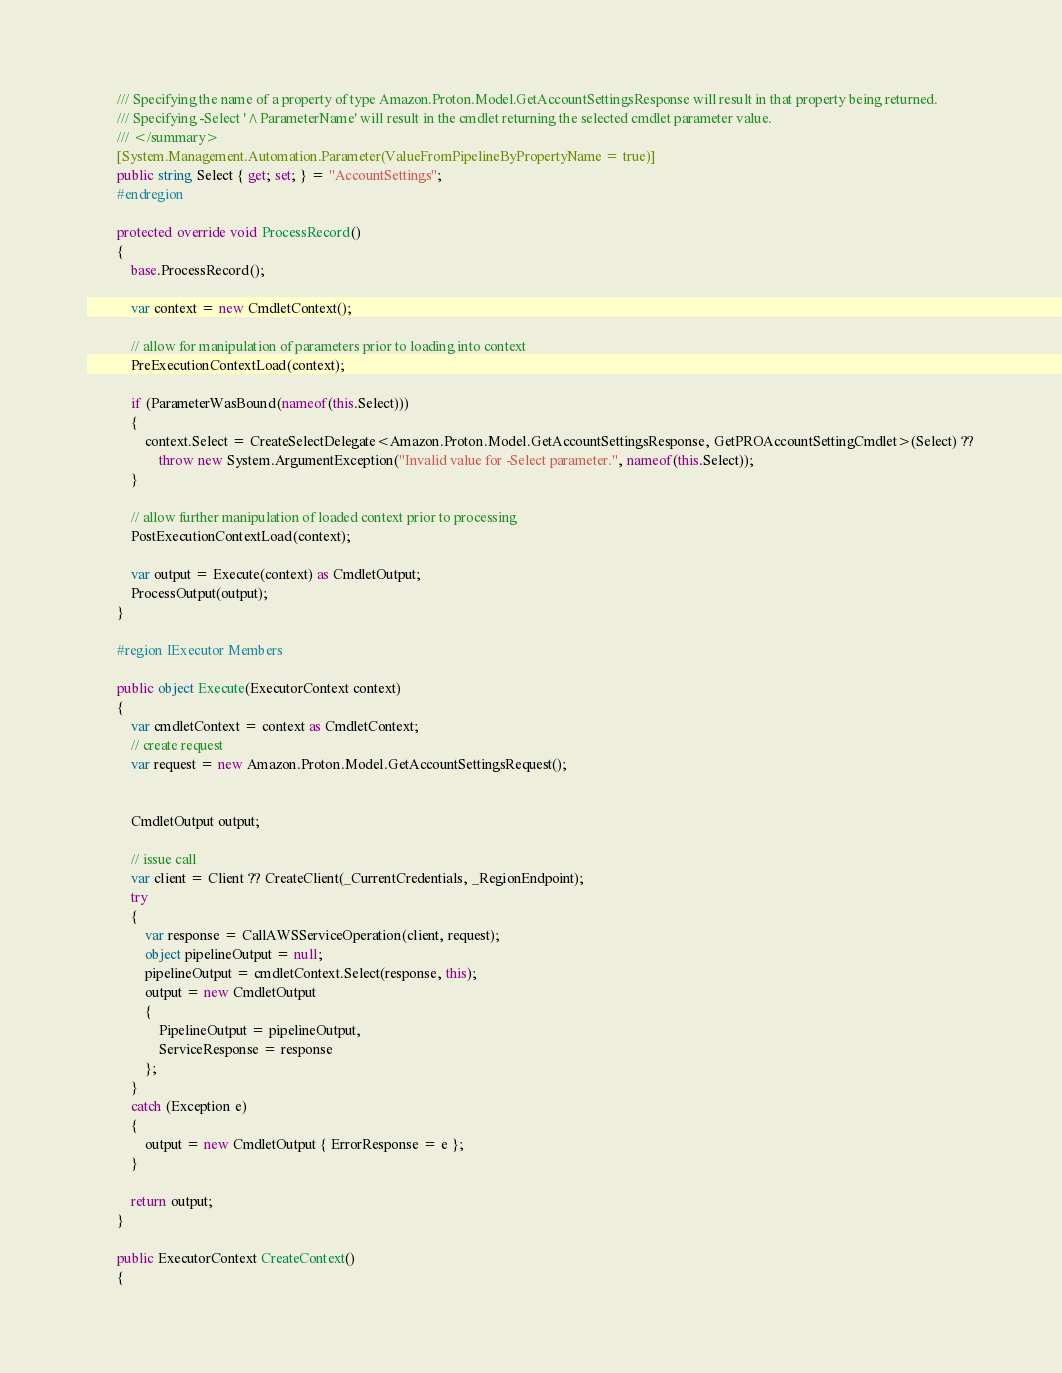<code> <loc_0><loc_0><loc_500><loc_500><_C#_>        /// Specifying the name of a property of type Amazon.Proton.Model.GetAccountSettingsResponse will result in that property being returned.
        /// Specifying -Select '^ParameterName' will result in the cmdlet returning the selected cmdlet parameter value.
        /// </summary>
        [System.Management.Automation.Parameter(ValueFromPipelineByPropertyName = true)]
        public string Select { get; set; } = "AccountSettings";
        #endregion
        
        protected override void ProcessRecord()
        {
            base.ProcessRecord();
            
            var context = new CmdletContext();
            
            // allow for manipulation of parameters prior to loading into context
            PreExecutionContextLoad(context);
            
            if (ParameterWasBound(nameof(this.Select)))
            {
                context.Select = CreateSelectDelegate<Amazon.Proton.Model.GetAccountSettingsResponse, GetPROAccountSettingCmdlet>(Select) ??
                    throw new System.ArgumentException("Invalid value for -Select parameter.", nameof(this.Select));
            }
            
            // allow further manipulation of loaded context prior to processing
            PostExecutionContextLoad(context);
            
            var output = Execute(context) as CmdletOutput;
            ProcessOutput(output);
        }
        
        #region IExecutor Members
        
        public object Execute(ExecutorContext context)
        {
            var cmdletContext = context as CmdletContext;
            // create request
            var request = new Amazon.Proton.Model.GetAccountSettingsRequest();
            
            
            CmdletOutput output;
            
            // issue call
            var client = Client ?? CreateClient(_CurrentCredentials, _RegionEndpoint);
            try
            {
                var response = CallAWSServiceOperation(client, request);
                object pipelineOutput = null;
                pipelineOutput = cmdletContext.Select(response, this);
                output = new CmdletOutput
                {
                    PipelineOutput = pipelineOutput,
                    ServiceResponse = response
                };
            }
            catch (Exception e)
            {
                output = new CmdletOutput { ErrorResponse = e };
            }
            
            return output;
        }
        
        public ExecutorContext CreateContext()
        {</code> 